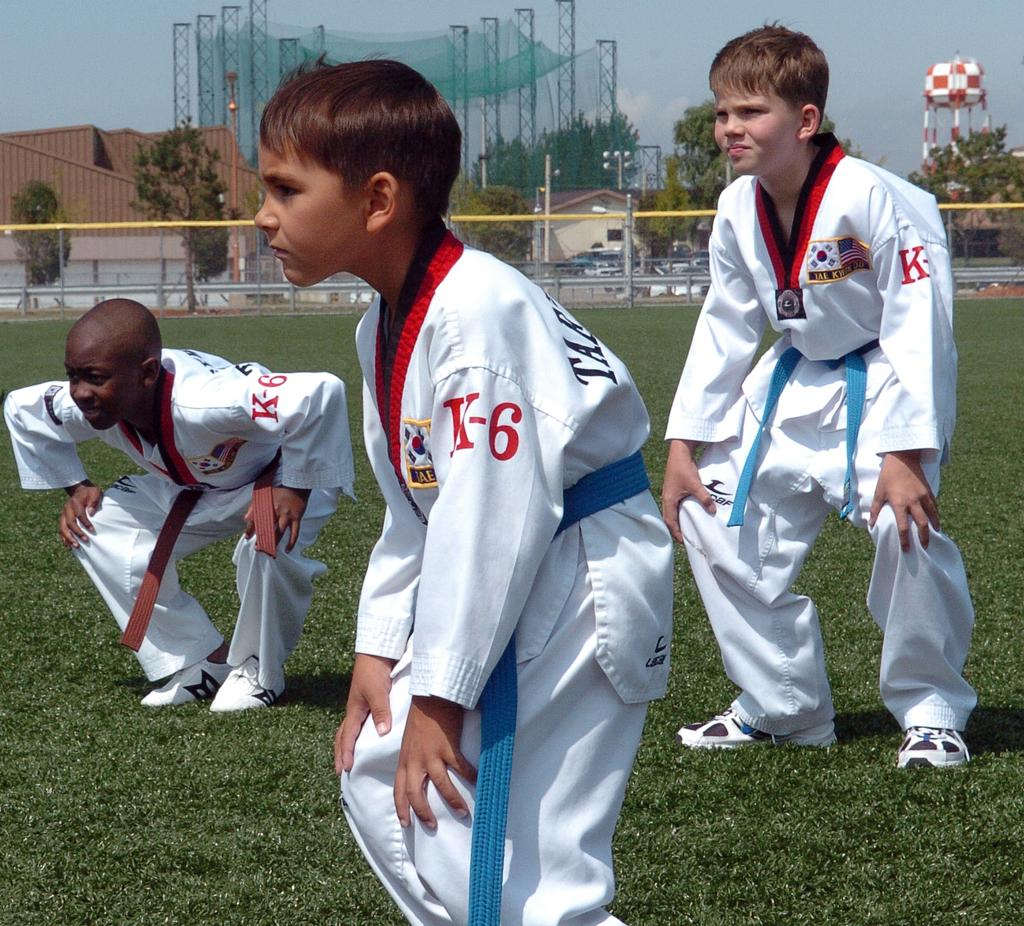<image>
Offer a succinct explanation of the picture presented. Young athletes in white uniforms that have K-6 in red letters on the left arm. 